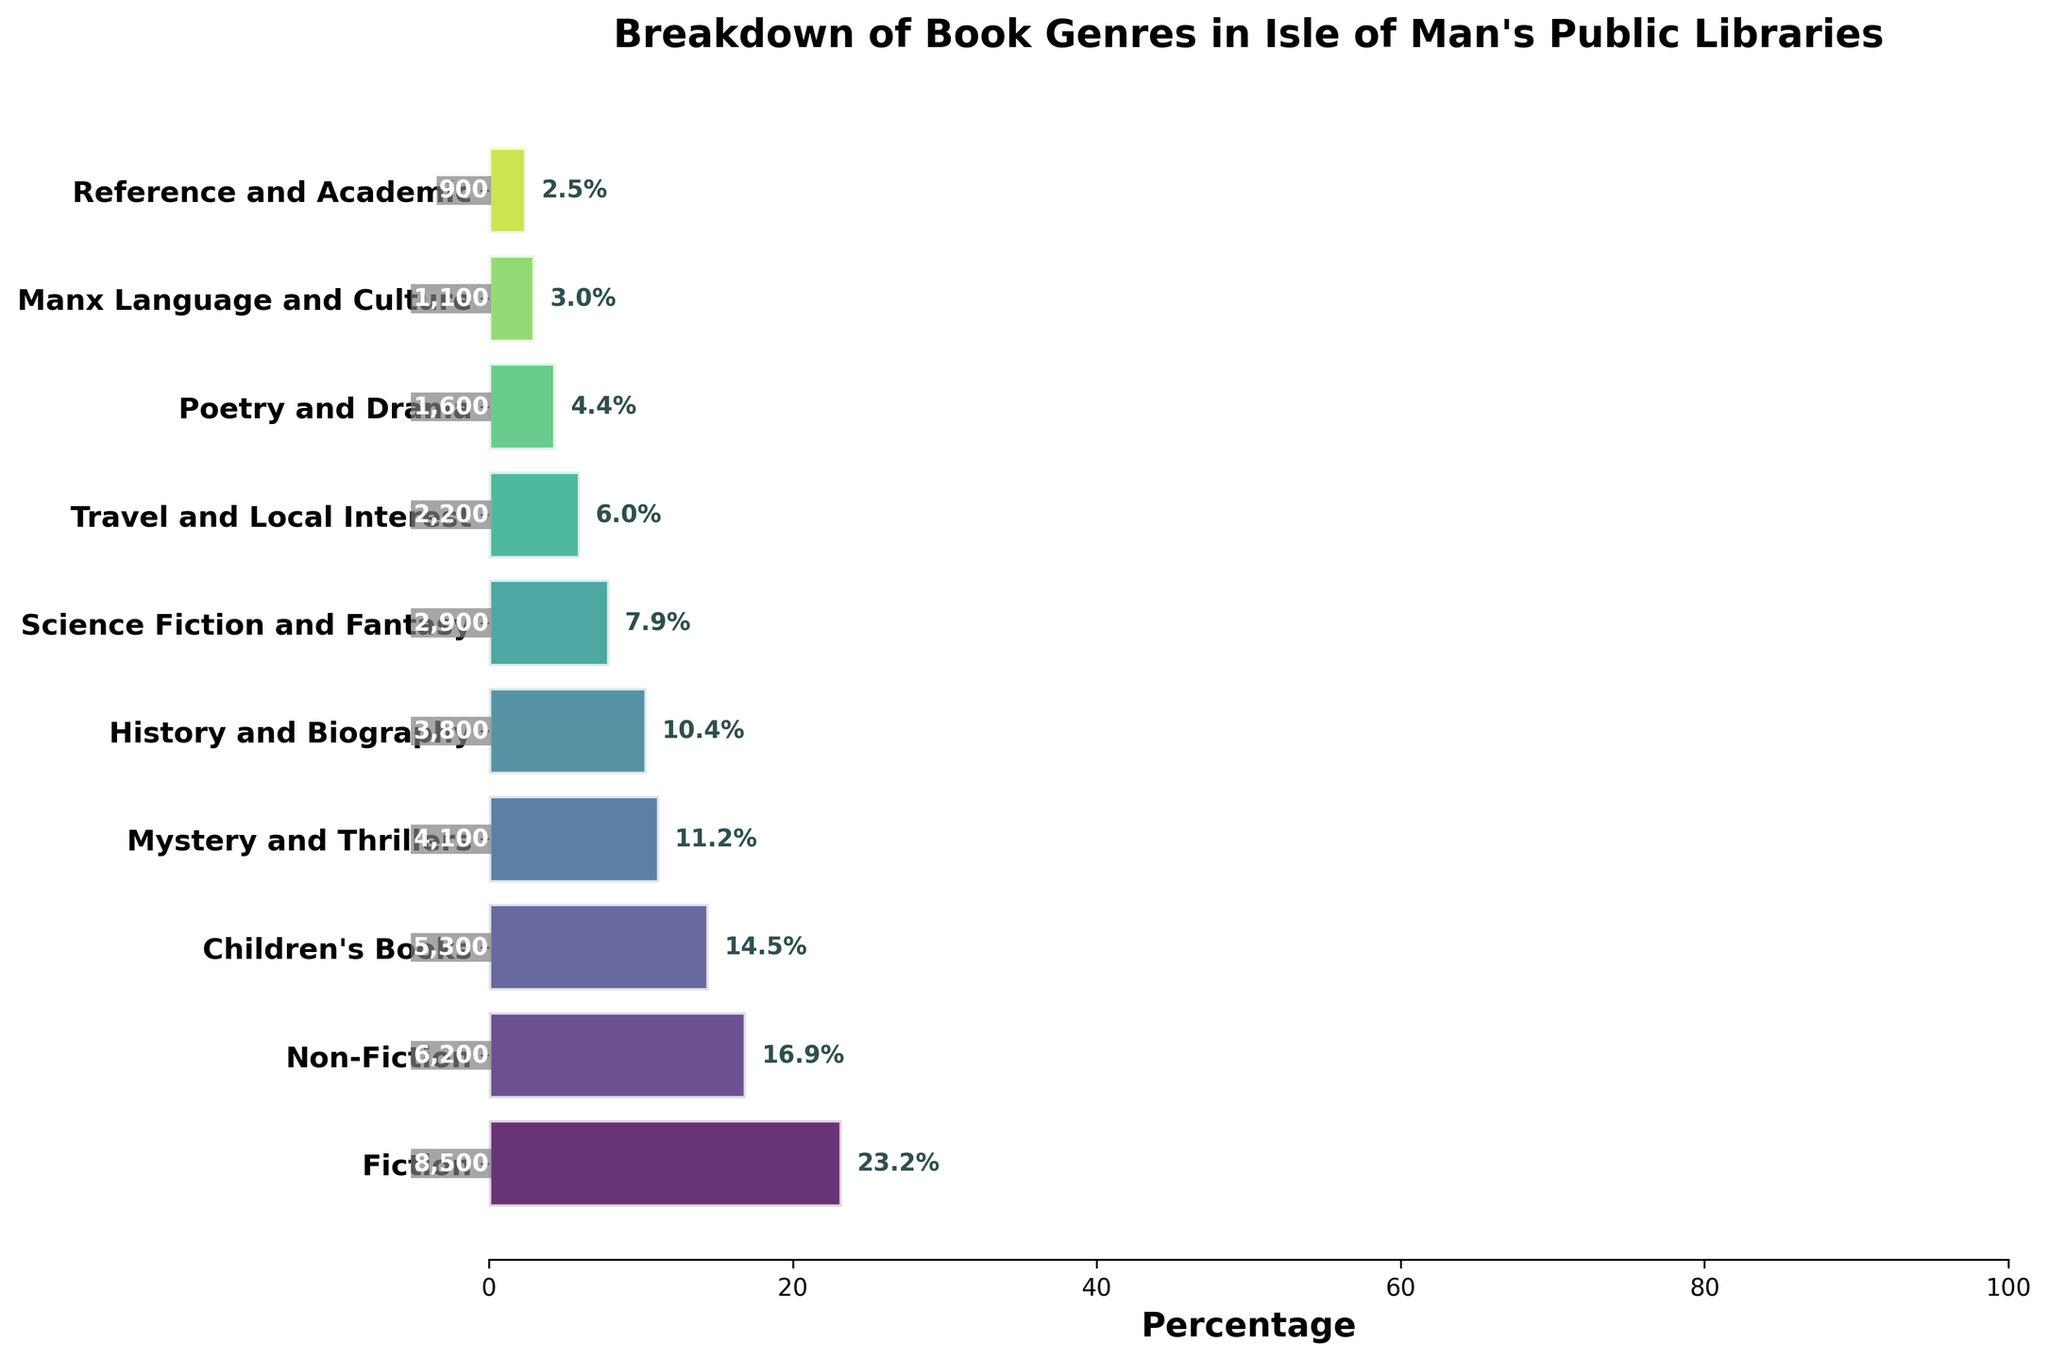Which genre is the most popular in Isle of Man's public libraries? The most popular genre can be identified by looking at the bar with the highest percentage on the funnel chart. The genre 'Fiction' has the highest percentage.
Answer: Fiction Which genre has a popularity of 5300? By looking at the genre labels and the corresponding popularity numbers on the bar, 'Children's Books' has a popularity of 5300.
Answer: Children's Books What is the total percentage of 'History and Biography' and 'Science Fiction and Fantasy'? First, find the percentages for both genres from the funnel chart. 'History and Biography' has approximately 13.6% and 'Science Fiction and Fantasy' has approximately 10.4%. Adding them gives 13.6% + 10.4% = 24.0%.
Answer: 24.0% Which genre is less popular, 'Poetry and Drama' or 'Manx Language and Culture'? By comparing the percentages, 'Poetry and Drama' has 5.7% and 'Manx Language and Culture' has 3.9%. Therefore, 'Manx Language and Culture' is less popular.
Answer: Manx Language and Culture What percentage does the 'Non-Fiction' genre represent? Look at the funnel chart and find the percentage label for 'Non-Fiction'. It represents approximately 22.1%.
Answer: 22.1% How many genres have a popularity count over 4000? By looking at the popularity labels on the bars, 'Fiction', 'Non-Fiction', 'Children's Books', and 'Mystery and Thrillers' each have a count over 4000. That makes four genres.
Answer: 4 What is the least popular genre in Isle of Man's public libraries? The least popular genre is represented by the bar with the smallest percentage. 'Reference and Academic' has the smallest percentage and popularity count.
Answer: Reference and Academic What is the difference in popularity count between 'Travel and Local Interest' and 'Poetry and Drama'? 'Travel and Local Interest' has a popularity count of 2200 and 'Poetry and Drama' has 1600. The difference is 2200 - 1600 = 600.
Answer: 600 In what position does 'Mystery and Thrillers' rank in terms of popularity? Looking at the funnel chart, 'Mystery and Thrillers' is the fourth most popular genre.
Answer: 4 